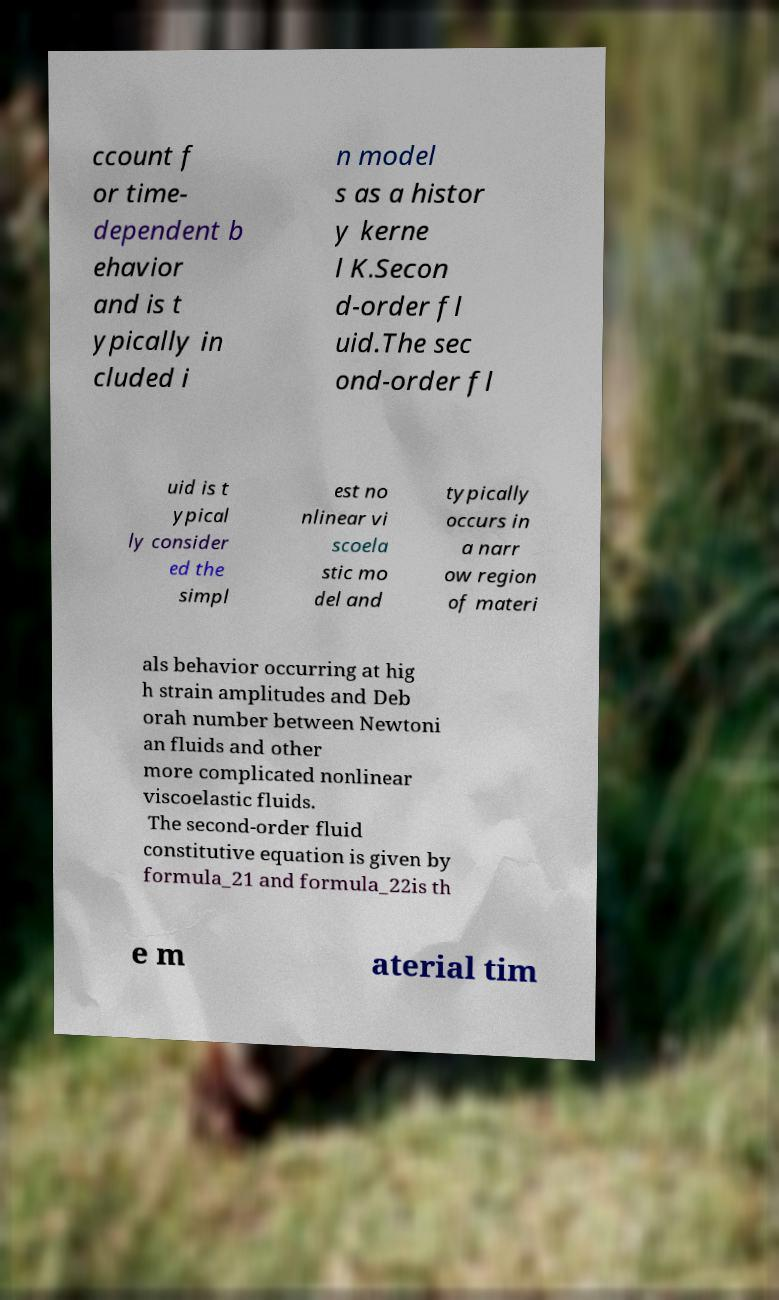Can you read and provide the text displayed in the image?This photo seems to have some interesting text. Can you extract and type it out for me? ccount f or time- dependent b ehavior and is t ypically in cluded i n model s as a histor y kerne l K.Secon d-order fl uid.The sec ond-order fl uid is t ypical ly consider ed the simpl est no nlinear vi scoela stic mo del and typically occurs in a narr ow region of materi als behavior occurring at hig h strain amplitudes and Deb orah number between Newtoni an fluids and other more complicated nonlinear viscoelastic fluids. The second-order fluid constitutive equation is given by formula_21 and formula_22is th e m aterial tim 